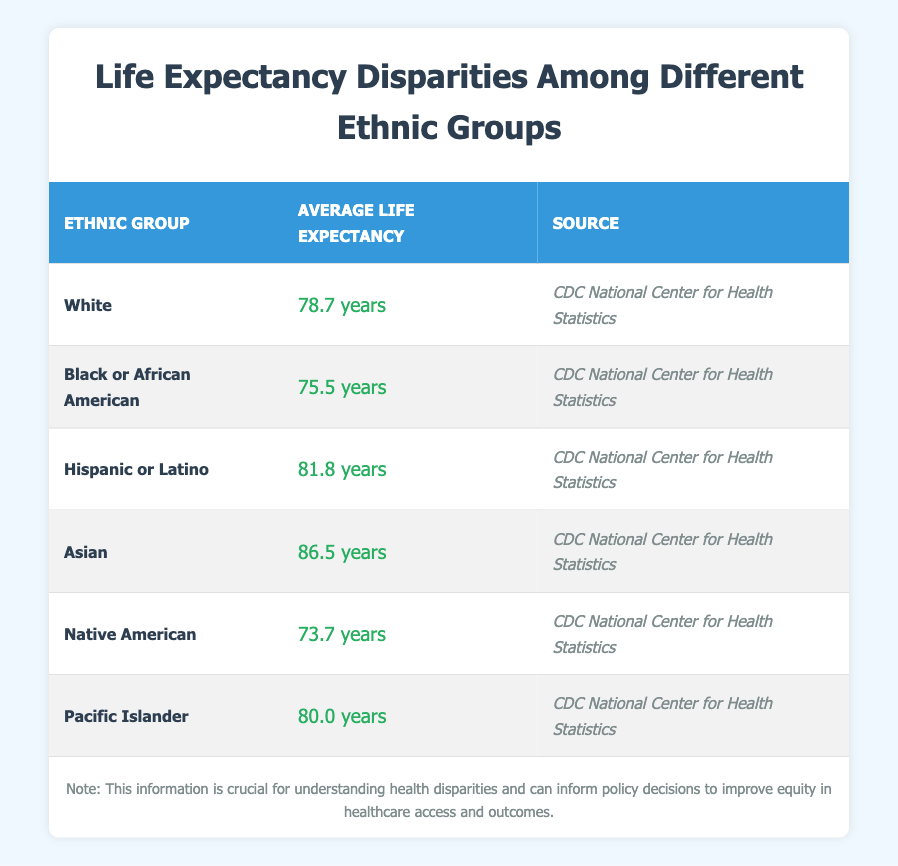What is the average life expectancy of Asian individuals? The table shows that the average life expectancy for the Asian ethnic group is 86.5 years.
Answer: 86.5 years Which ethnic group has the highest average life expectancy? By comparing the values in the table, the Asian ethnic group has the highest average life expectancy at 86.5 years.
Answer: Asian What is the average life expectancy difference between White and Black or African American individuals? The average life expectancy for White individuals is 78.7 years, and for Black or African American individuals, it is 75.5 years. The difference is calculated as 78.7 - 75.5 = 3.2 years.
Answer: 3.2 years Is it true that Native American individuals have a higher average life expectancy than Pacific Islander individuals? The table shows that Native Americans have an average life expectancy of 73.7 years, while Pacific Islanders have an average of 80.0 years. Therefore, the statement is false.
Answer: No What is the total average life expectancy of all groups combined? First, sum the average life expectancies of all groups: 78.7 + 75.5 + 81.8 + 86.5 + 73.7 + 80.0 = 476.2 years. Then, divide by the number of groups (6): 476.2 / 6 = 79.37 years.
Answer: 79.37 years What is the average life expectancy of Hispanic or Latino individuals compared to Black or African American individuals? Hispanic or Latino individuals have an average life expectancy of 81.8 years, while Black or African American individuals have 75.5 years. Comparing these values shows that Hispanic or Latino individuals live longer than Black or African American individuals by 6.3 years.
Answer: 6.3 years Which ethnic group has the lowest average life expectancy? The table indicates that the Native American ethnic group has the lowest average life expectancy at 73.7 years.
Answer: Native American Are Black or African American individuals more likely to have a shorter life expectancy than White individuals? The average life expectancy for Black or African American individuals is 75.5 years, while for White individuals, it is 78.7 years. Therefore, it is true that Black or African American individuals have a shorter life expectancy.
Answer: Yes 